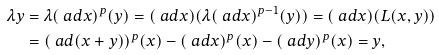<formula> <loc_0><loc_0><loc_500><loc_500>\lambda y & = \lambda ( \ a d x ) ^ { p } ( y ) = ( \ a d x ) ( \lambda ( \ a d x ) ^ { p - 1 } ( y ) ) = ( \ a d x ) ( L ( x , y ) ) \\ & = ( \ a d ( x + y ) ) ^ { p } ( x ) - ( \ a d x ) ^ { p } ( x ) - ( \ a d y ) ^ { p } ( x ) = y ,</formula> 